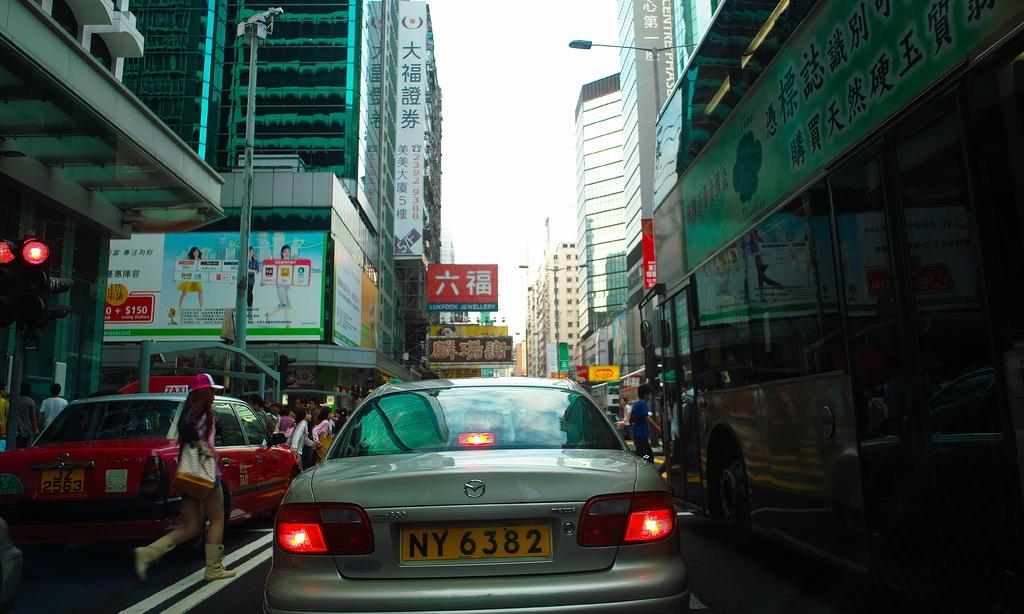Provide a one-sentence caption for the provided image. A car with the license plate NY 6282 is stuck in a traffic jam as people walk around the cars. 